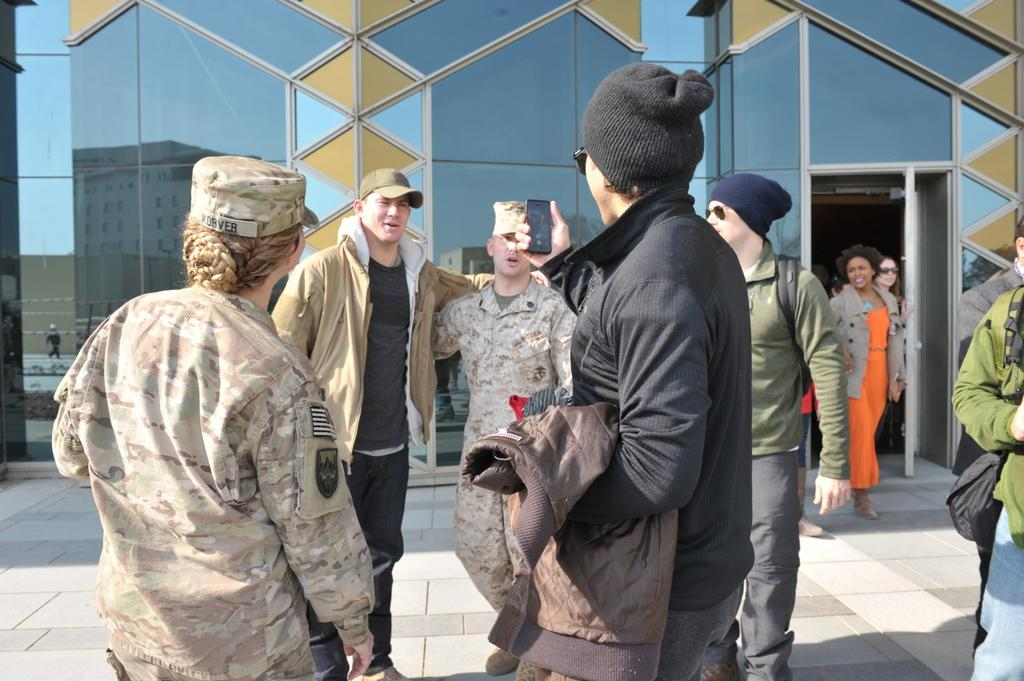How many people are in the image? There are persons standing in the image. What is the surface on which the persons are standing? The persons are standing on the floor. What can be seen in the background of the image? There is a building with glass in the background of the image. What type of payment is being made by the cook in the image? There is no cook or payment present in the image. How many women are visible in the image? The provided facts do not specify the gender of the persons in the image, so we cannot determine the number of women. 